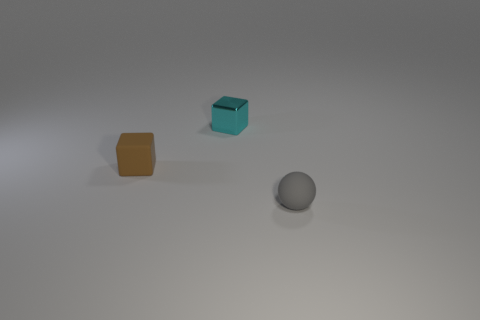Is the number of small gray rubber spheres in front of the gray sphere less than the number of gray balls that are in front of the tiny cyan metallic block?
Your answer should be compact. Yes. Is the number of small objects that are to the left of the small metal block less than the number of large yellow shiny cylinders?
Keep it short and to the point. No. What is the material of the thing that is right of the cyan metal cube that is to the right of the matte object left of the small gray thing?
Your response must be concise. Rubber. How many objects are either cubes that are on the left side of the metal object or things to the right of the small brown rubber block?
Keep it short and to the point. 3. There is another thing that is the same shape as the metal thing; what is it made of?
Offer a terse response. Rubber. How many metallic objects are either small cyan cubes or big brown blocks?
Offer a very short reply. 1. There is a brown thing that is the same material as the small gray thing; what shape is it?
Ensure brevity in your answer.  Cube. How many other tiny metal things have the same shape as the tiny cyan thing?
Your response must be concise. 0. There is a matte object that is on the left side of the small gray thing; is it the same shape as the small thing that is behind the brown matte cube?
Make the answer very short. Yes. What number of things are small matte balls or cyan metallic cubes that are on the right side of the small brown rubber cube?
Provide a short and direct response. 2. 